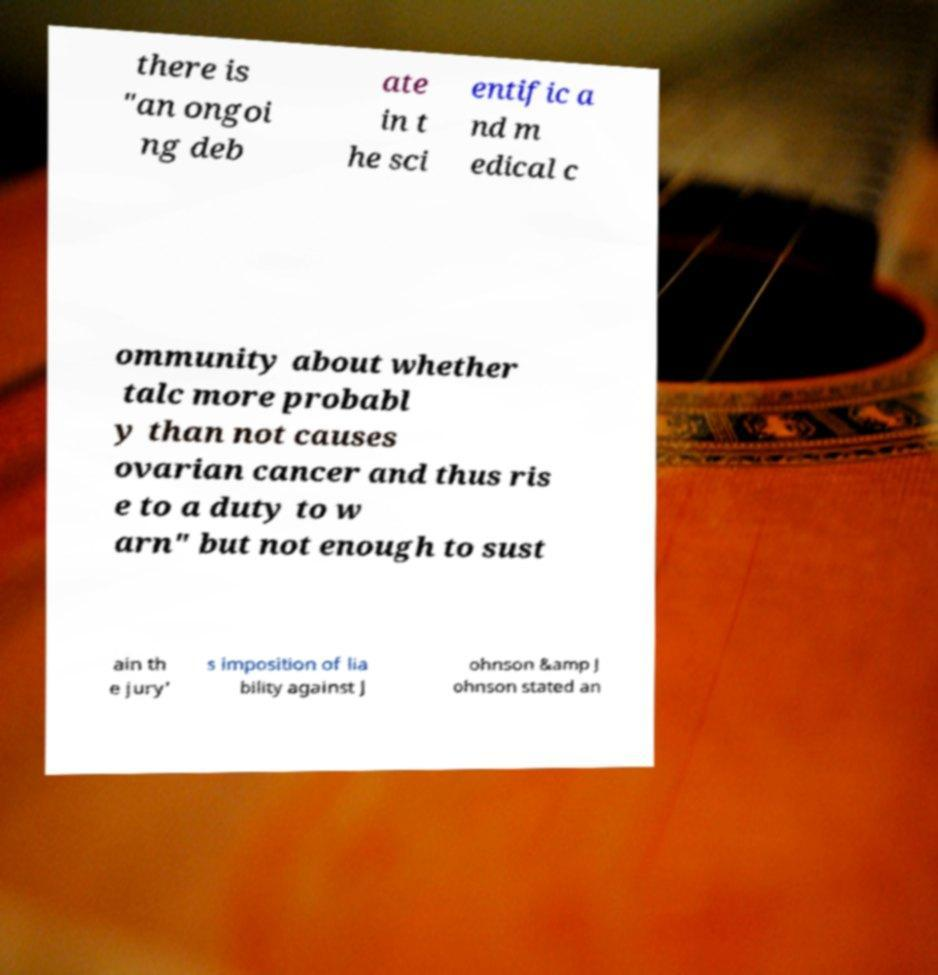Can you accurately transcribe the text from the provided image for me? there is "an ongoi ng deb ate in t he sci entific a nd m edical c ommunity about whether talc more probabl y than not causes ovarian cancer and thus ris e to a duty to w arn" but not enough to sust ain th e jury' s imposition of lia bility against J ohnson &amp J ohnson stated an 